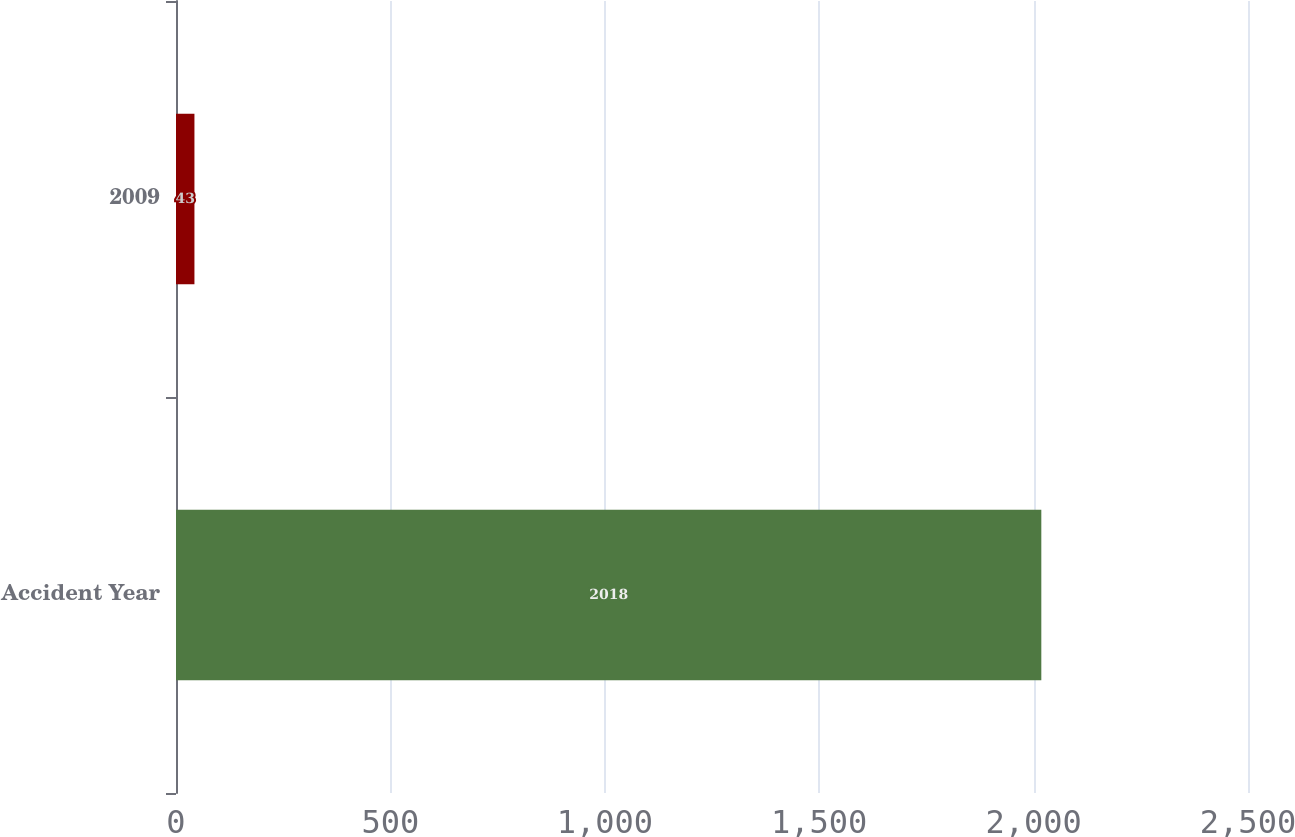Convert chart. <chart><loc_0><loc_0><loc_500><loc_500><bar_chart><fcel>Accident Year<fcel>2009<nl><fcel>2018<fcel>43<nl></chart> 